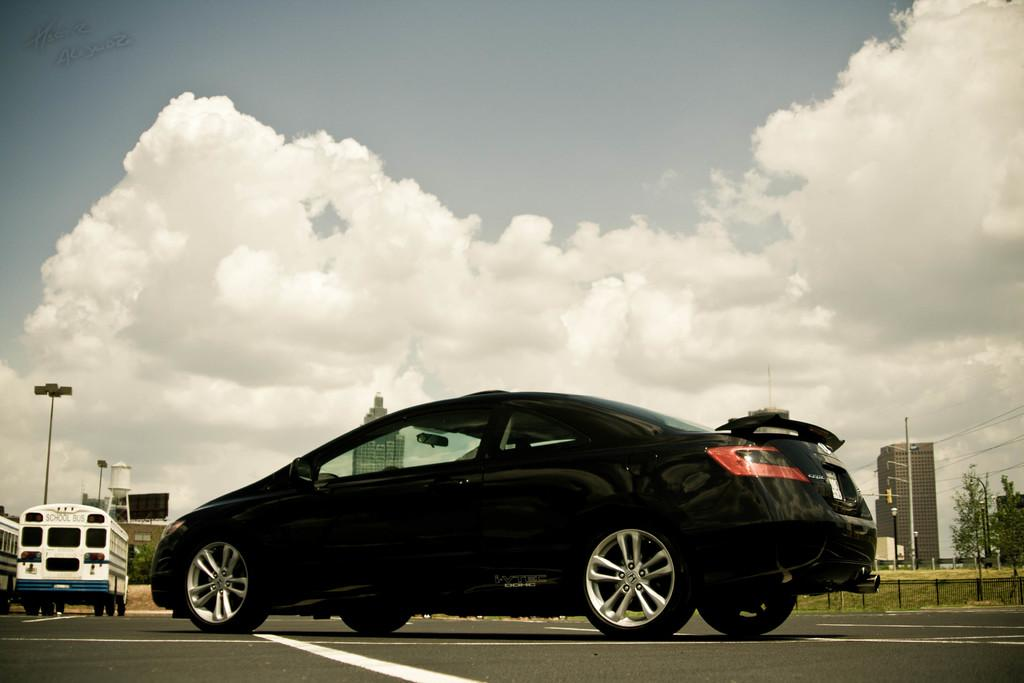What is happening on the road in the image? There are two vehicles moving on the road. What can be seen in the background of the image? There are buildings, poles, trees, and the sky visible in the background. Can you describe the vehicles on the road? The provided facts do not give specific details about the vehicles, so we cannot describe them further. Who is the creator of the sun in the image? There is no sun present in the image, so it is not possible to determine the creator of the sun. 